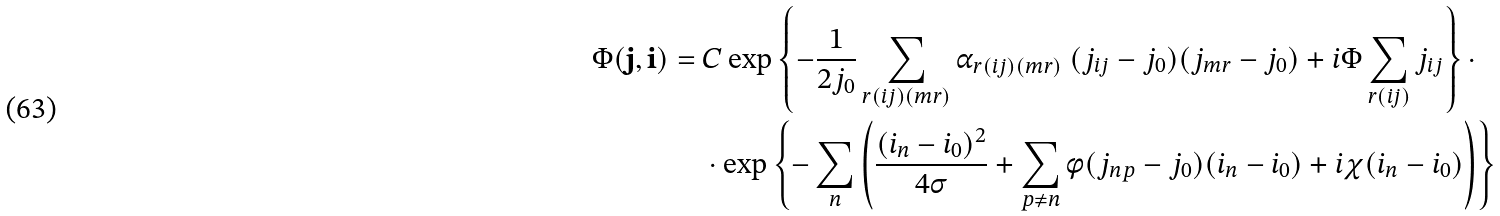<formula> <loc_0><loc_0><loc_500><loc_500>\Phi ( { \mathbf j } , { \mathbf i } ) = \ & C \exp \left \{ - \frac { 1 } { 2 j _ { 0 } } \sum _ { r { ( i j ) ( m r ) } } \alpha _ { r { ( i j ) ( m r ) } } \ ( j _ { i j } - j _ { 0 } ) ( j _ { m r } - j _ { 0 } ) + i \Phi \sum _ { r { ( i j ) } } j _ { i j } \right \} \cdot \\ & \cdot \exp \left \{ - \sum _ { n } \left ( \frac { ( i _ { n } - i _ { 0 } ) ^ { 2 } } { 4 \sigma } + \sum _ { p \neq n } \phi ( j _ { n p } - j _ { 0 } ) ( i _ { n } - i _ { 0 } ) + i \chi ( i _ { n } - i _ { 0 } ) \right ) \right \}</formula> 